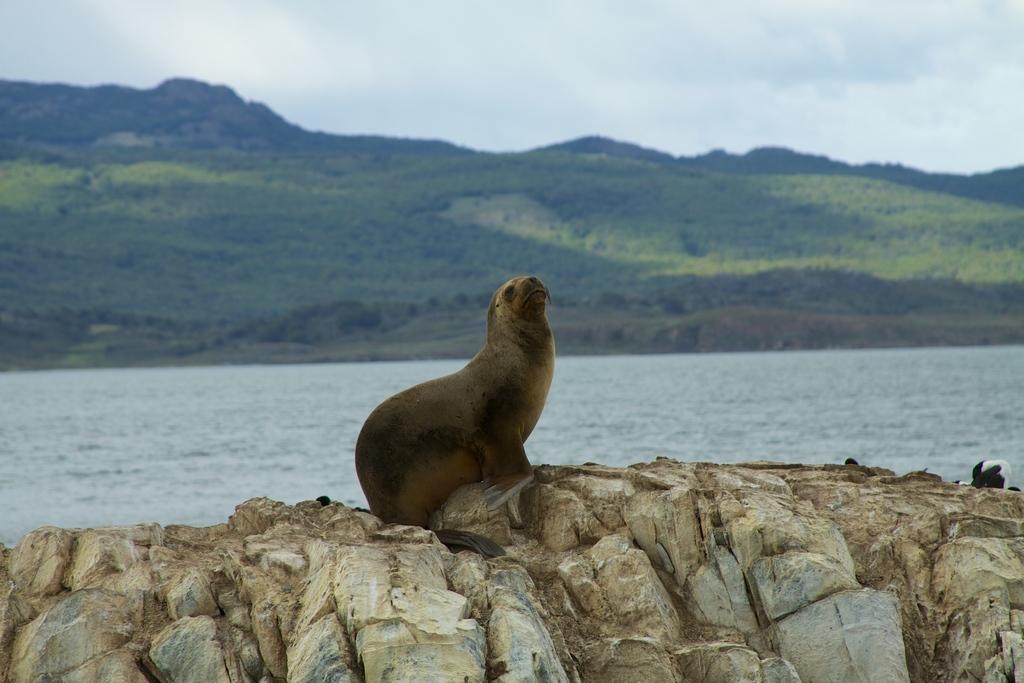How would you summarize this image in a sentence or two? In the foreground of the picture we can see a seal on a rock. In the middle we can see water body and greenery on a hill. At the top it is sky. On the right there is a black and white color object. 